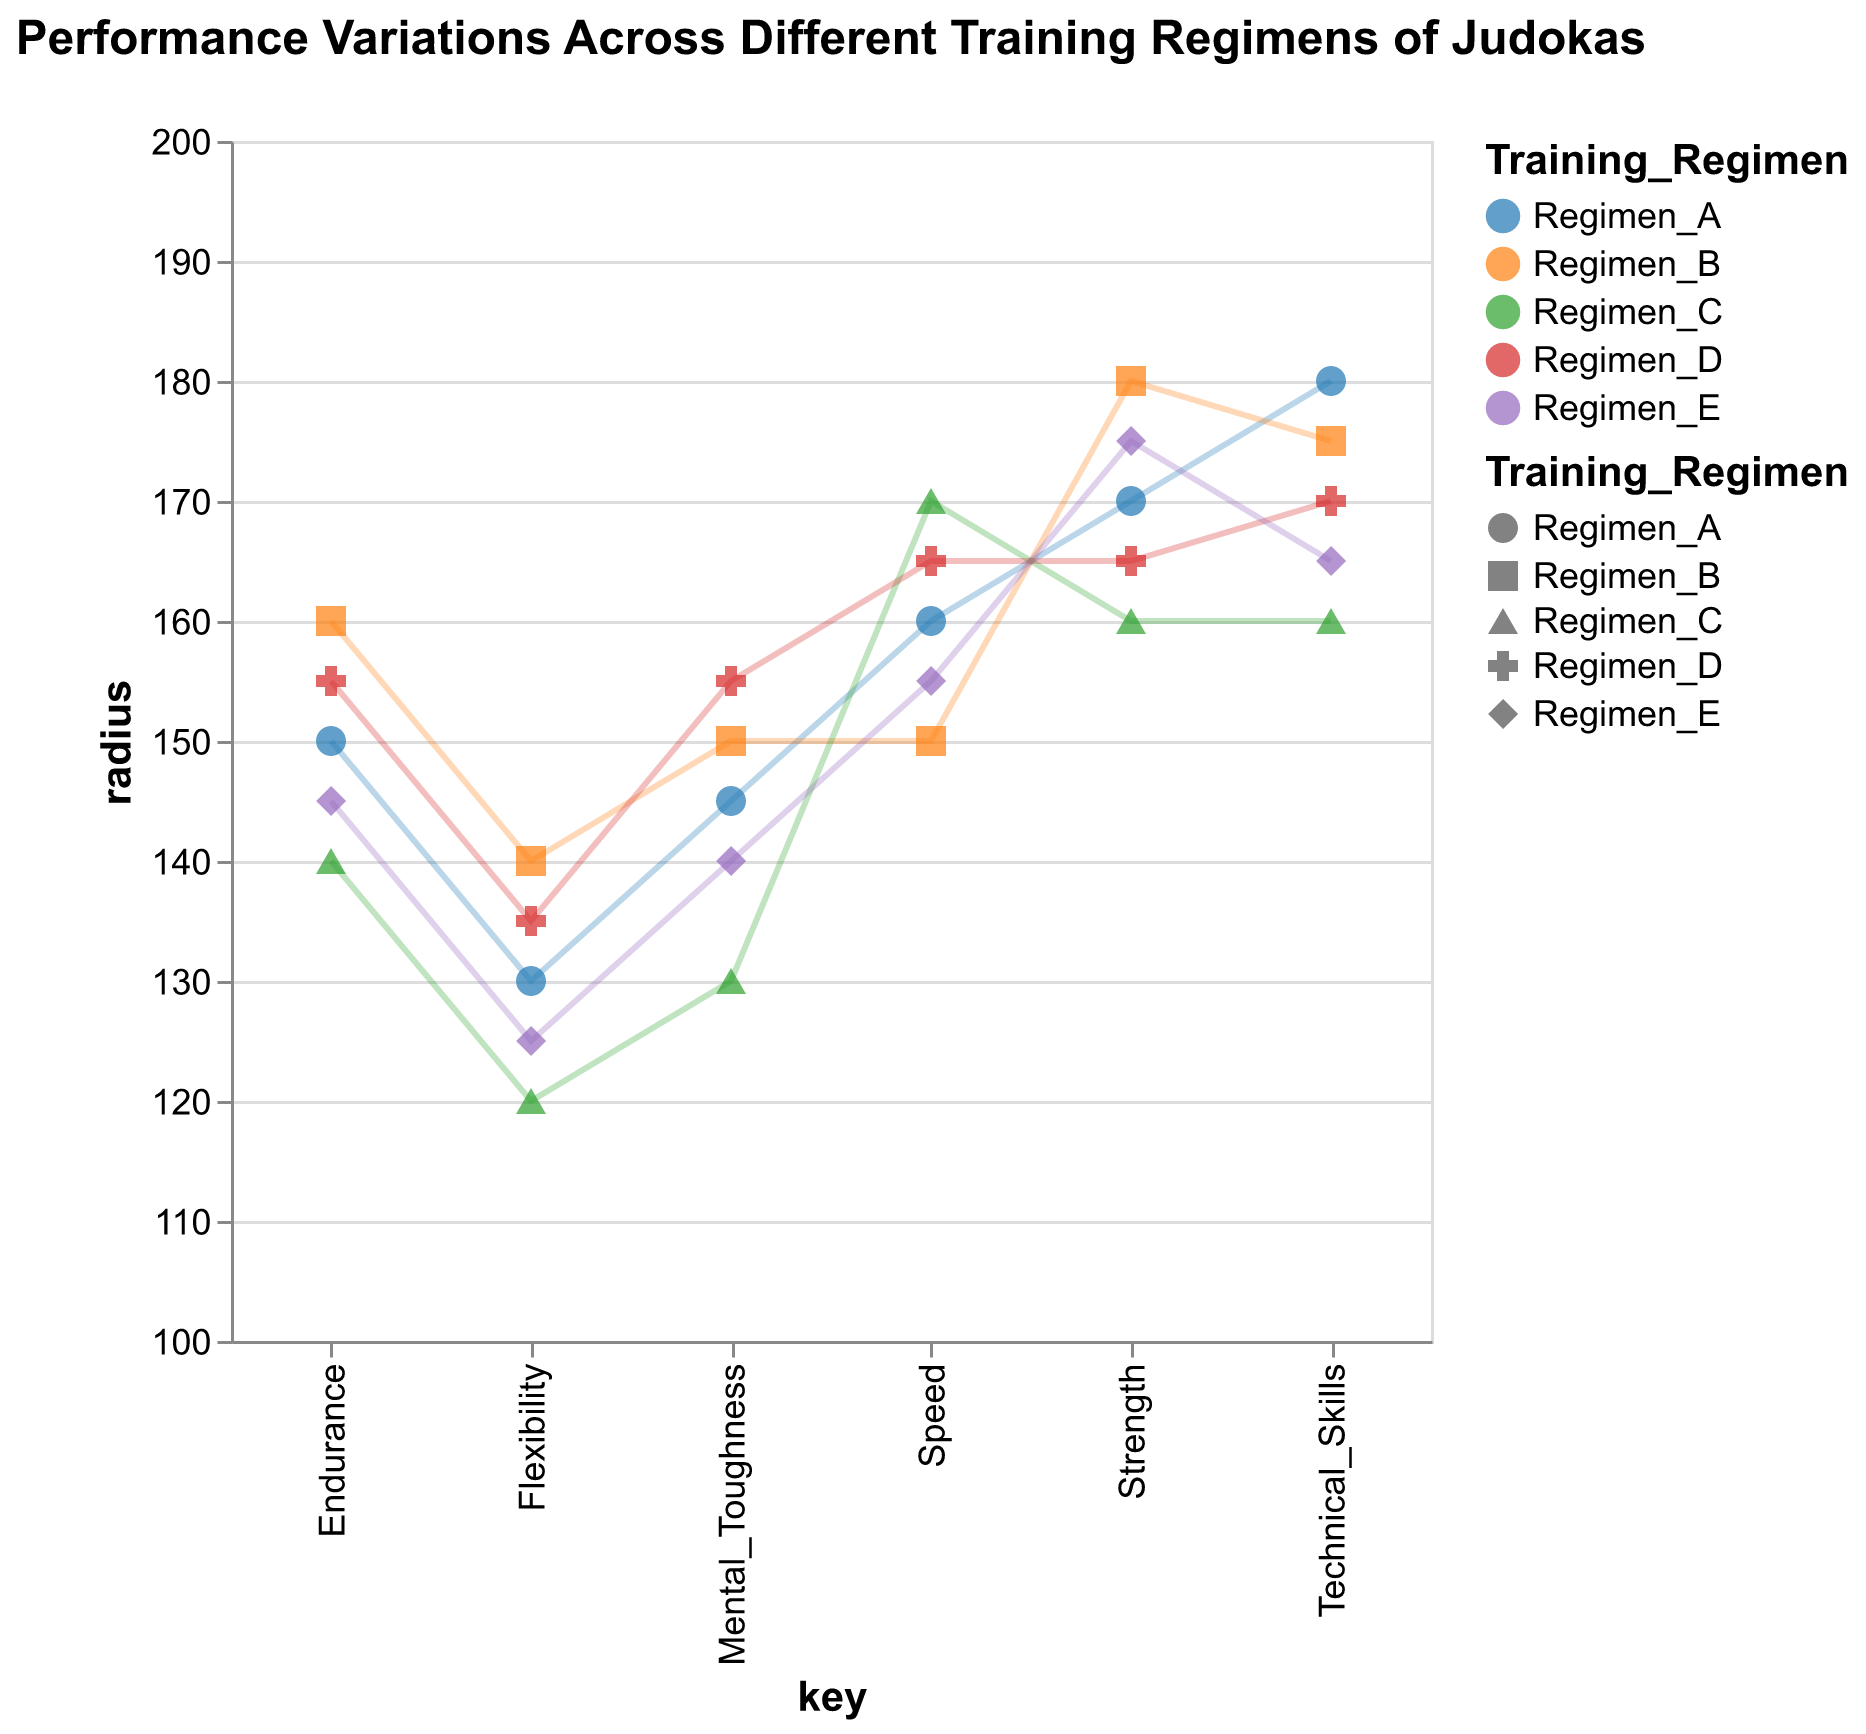What is the title of the plot? The title is displayed at the top center of the chart.
Answer: Performance Variations Across Different Training Regimens of Judokas How many training regimens are compared in this plot? By observing the legend or the color-coded points/lines, we can see there are five different training regimens being compared.
Answer: Five Which training regimen shows the highest endurance? By looking at the endurance category on the plot and identifying the highest value, Regimen B has the highest score of 160 in endurance.
Answer: Regimen B What is the average mental toughness across all regimens? We need to sum the mental toughness values for each regimen and then divide by the number of regimens. So, (145 + 150 + 130 + 155 + 140) / 5 = 720 / 5 = 144.
Answer: 144 Between Regimen A and Regimen E, which has a higher strength value? By comparing the strength values in the plot, Regimen A has a strength of 170 and Regimen E has a strength of 175. Regimen E is higher.
Answer: Regimen E Which attribute shows the most variation across the different training regimens? We need to compare the range of values for each attribute across all regimens. Flexibility has the largest range, from 120 to 140.
Answer: Flexibility Among all regimens, which has the highest technical skills? We observe the technical skills values and identify the highest one. Regimen A has the highest technical skills value of 180.
Answer: Regimen A 